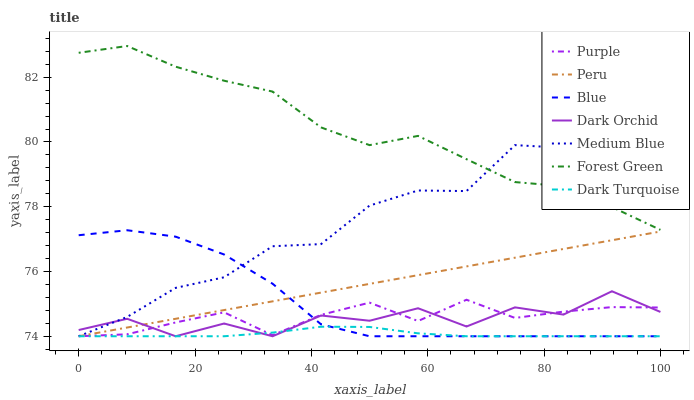Does Dark Turquoise have the minimum area under the curve?
Answer yes or no. Yes. Does Forest Green have the maximum area under the curve?
Answer yes or no. Yes. Does Purple have the minimum area under the curve?
Answer yes or no. No. Does Purple have the maximum area under the curve?
Answer yes or no. No. Is Peru the smoothest?
Answer yes or no. Yes. Is Medium Blue the roughest?
Answer yes or no. Yes. Is Purple the smoothest?
Answer yes or no. No. Is Purple the roughest?
Answer yes or no. No. Does Blue have the lowest value?
Answer yes or no. Yes. Does Forest Green have the lowest value?
Answer yes or no. No. Does Forest Green have the highest value?
Answer yes or no. Yes. Does Purple have the highest value?
Answer yes or no. No. Is Dark Orchid less than Forest Green?
Answer yes or no. Yes. Is Forest Green greater than Dark Turquoise?
Answer yes or no. Yes. Does Dark Turquoise intersect Medium Blue?
Answer yes or no. Yes. Is Dark Turquoise less than Medium Blue?
Answer yes or no. No. Is Dark Turquoise greater than Medium Blue?
Answer yes or no. No. Does Dark Orchid intersect Forest Green?
Answer yes or no. No. 